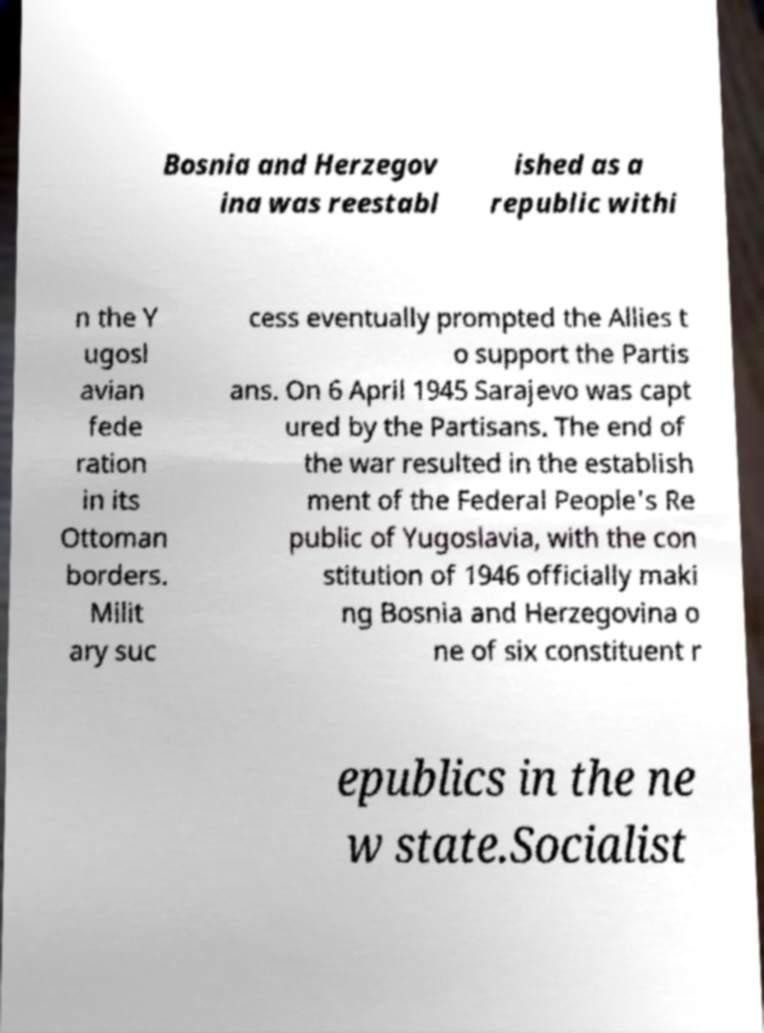Please read and relay the text visible in this image. What does it say? Bosnia and Herzegov ina was reestabl ished as a republic withi n the Y ugosl avian fede ration in its Ottoman borders. Milit ary suc cess eventually prompted the Allies t o support the Partis ans. On 6 April 1945 Sarajevo was capt ured by the Partisans. The end of the war resulted in the establish ment of the Federal People's Re public of Yugoslavia, with the con stitution of 1946 officially maki ng Bosnia and Herzegovina o ne of six constituent r epublics in the ne w state.Socialist 